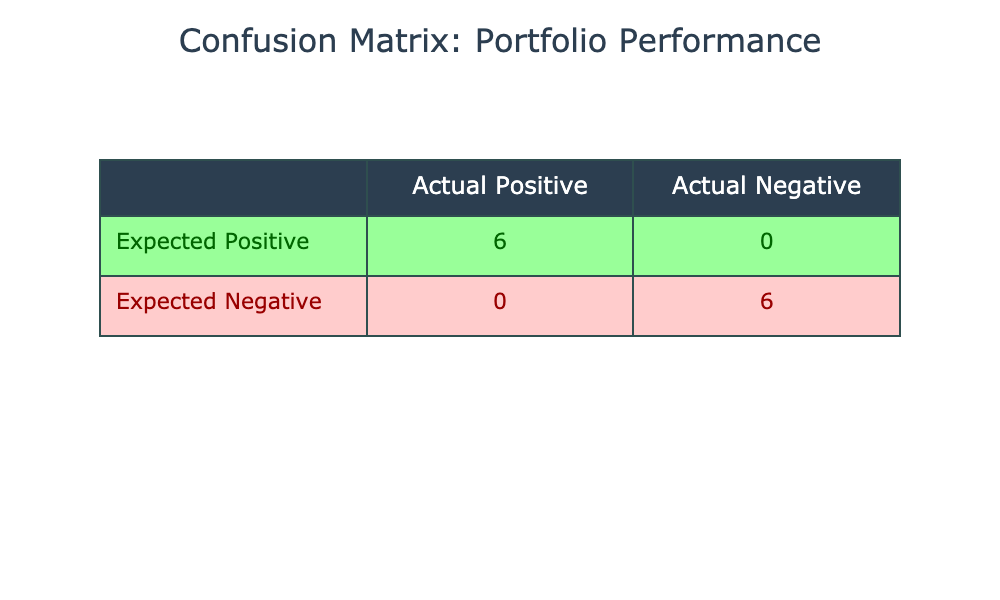What is the number of true positives in the confusion matrix? The true positives are the cases where both the actual and expected returns are classified as positive. In the table, the portfolios that are labeled as Positive and also have actual returns greater than or equal to expected returns are Tech Innovators, Healthcare Growth, Sustainable Growth Fund, Luxury Brands Portfolio, and Infrastructure Yield Fund. There are 5 such portfolios, so the number of true positives is 5.
Answer: 5 How many portfolios had negative actual returns? Negative actual returns are represented by portfolios with Actual Returns (%) less than expected returns. The portfolios identified in the table with negative performance indicators are Green Energy Fund, Global Diversified Assets, Emerging Markets Equity, Real Estate Investment Trusts, Consumer Goods Fund, and Telecom Giants. Counting these portfolios gives us a total of 6 portfolios with negative actual returns.
Answer: 6 What is the total number of false negatives in the confusion matrix? False negatives are the portfolios that are actually positive but have expected returns that is more than actual returns. From the table, the only portfolio that qualifies is the Green Energy Fund, Global Diversified Assets, Emerging Markets Equity, Real Estate Investment Trusts, Consumer Goods Fund, and Telecom Giants, none of which are positive according to the performance indicator. Hence, there are 0 false negatives.
Answer: 0 Is the number of expected positives greater than the number of actual positives? Expected positives are the cases where expected returns are less than or equal to actual returns. Actual positives are those classified as positive. After analyzing the portfolios, we find that there are 5 expected positives (Tech Innovators, Healthcare Growth, Sustainable Growth Fund, Luxury Brands Portfolio, and Infrastructure Yield Fund) and 5 actual positives. Since both numbers are the same, the number of expected positives is not greater than the actual positives.
Answer: No What is the ratio of true negatives to false positives? True negatives are identified as the cases where both actual and expected returns are negative whereas false positives are cases where actual returns are positive but expected returns are negative. The table shows that true negatives include the portfolios that were classified negative and had actual returns lesser than expected returns: Green Energy Fund, Global Diversified Assets, Emerging Markets Equity, and Telecom Giants, totaling 4 true negatives. The false positives identified from the table are 0, as there were no instances where expected negative returns were falsely classified as positive. The ratio results in division by zero, indicating it cannot be computed.
Answer: Undefined 